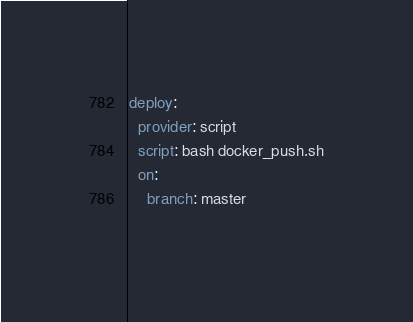Convert code to text. <code><loc_0><loc_0><loc_500><loc_500><_YAML_>deploy:
  provider: script
  script: bash docker_push.sh
  on:
    branch: master
    </code> 